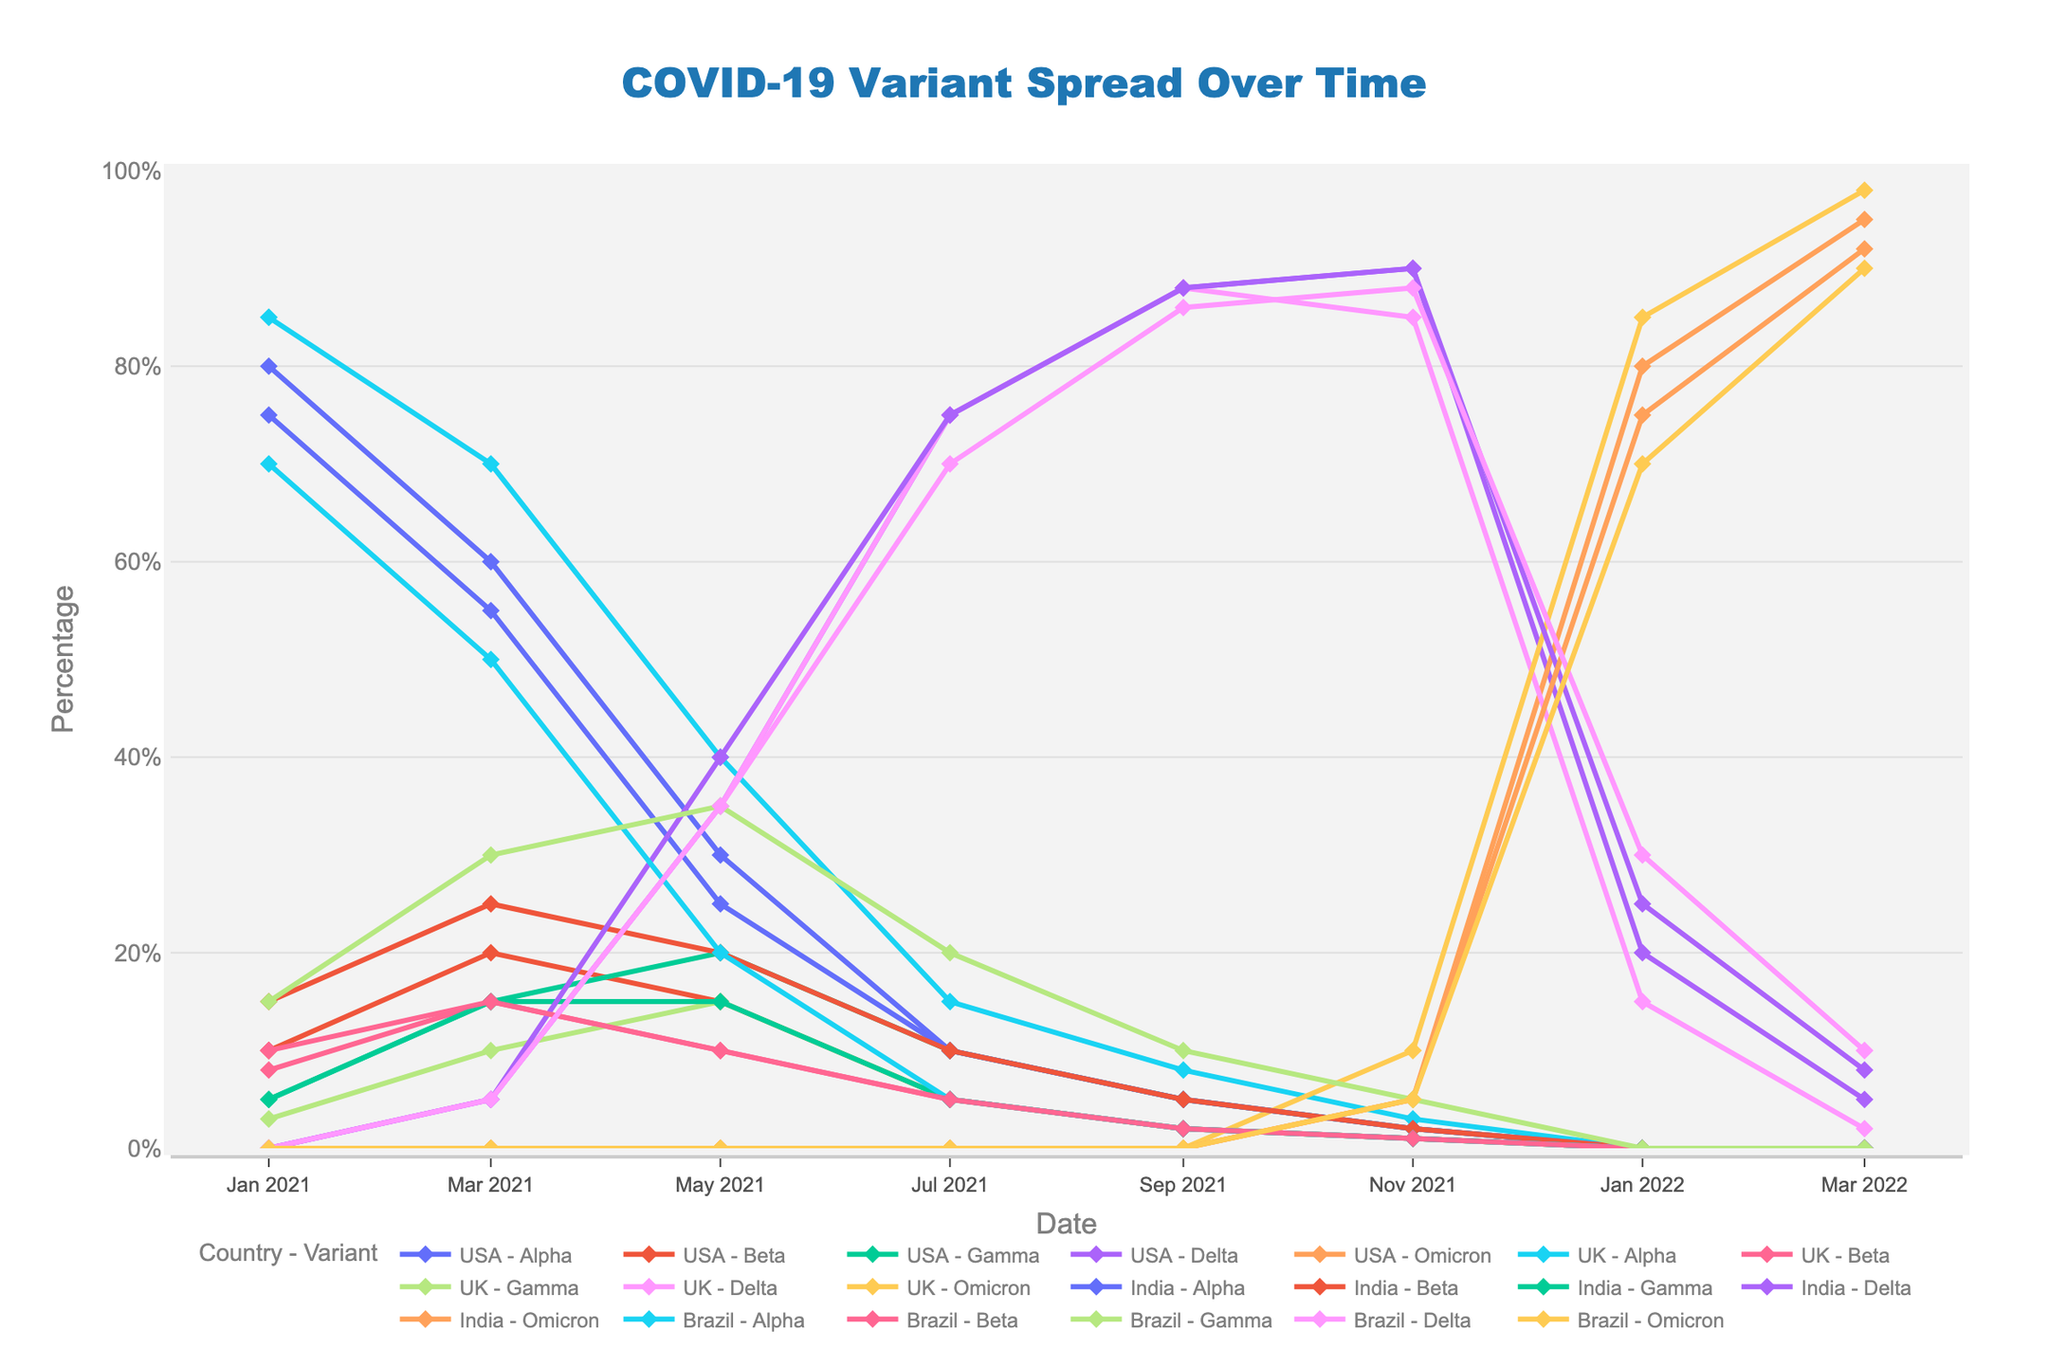Which COVID-19 variant had the highest percentage in the USA on March 1, 2022? Look at the lines corresponding to the USA and find the date March 1, 2022. Check the percentages for each variant and identify the highest one. Omicron has the highest percentage.
Answer: Omicron In which month and year did the Delta variant first surpass 70% in Brazil? Follow the line corresponding to Delta in Brazil and identify the first point where it surpasses 70%. This occurs in July 2021.
Answer: July 2021 Compare the trends of the Alpha variant in the UK and India. Which country had a higher percentage of the Alpha variant on May 1, 2021? Look at the lines for the Alpha variant in both the UK and India and identify the data points for May 1, 2021. The UK had 40% and India had 25%.
Answer: UK What is the difference in the percentage of the Omicron variant between the USA and India on January 1, 2022? Find the data points for Omicron in the USA and India on January 1, 2022. Calculate the difference: 80% (USA) - 75% (India) = 5%.
Answer: 5% How did the Beta variant change in percentage in the UK from January 1, 2021, to March 1, 2021? Find the percentage of the Beta variant in the UK on January 1, 2021, and March 1, 2021, and calculate the difference: 15% - 8% = 7%.
Answer: Increased by 7% Which variant had the highest increase in percentage in Brazil between March 1, 2021 and May 1, 2021? Look at the lines for Brazil between these dates and measure the percentage increase for each variant. Gamma increased from 30% to 35% (5%), Delta increased from 5% to 35% (30%). Delta had the highest increase.
Answer: Delta What can you infer about the trend of the Gamma variant in Brazil over the shown period? Observe the Gamma variant line in Brazil. Initially, it increases until May 2021 but then decreases over time, indicating it was replaced by other variants.
Answer: Initial rise, then fall Among the listed countries, which one had the latest significant emergence of the Omicron variant? Identify when Omicron first shows a high percentage in each country. Brazil sees significant Omicron levels in January 2022 while others have it earlier.
Answer: Brazil What is the aggregate percentage of all variants in the USA on November 1, 2021? Sum the percentages of all variants on that date in the USA: 2% (Alpha) + 1% (Beta) + 2% (Gamma) + 90% (Delta) + 5% (Omicron) = 100%.
Answer: 100% Which country's Delta variant peaked first among the four countries? Find the peak points of the Delta variant for each country and compare dates. The Delta variant peaked first in India around July 2021.
Answer: India 